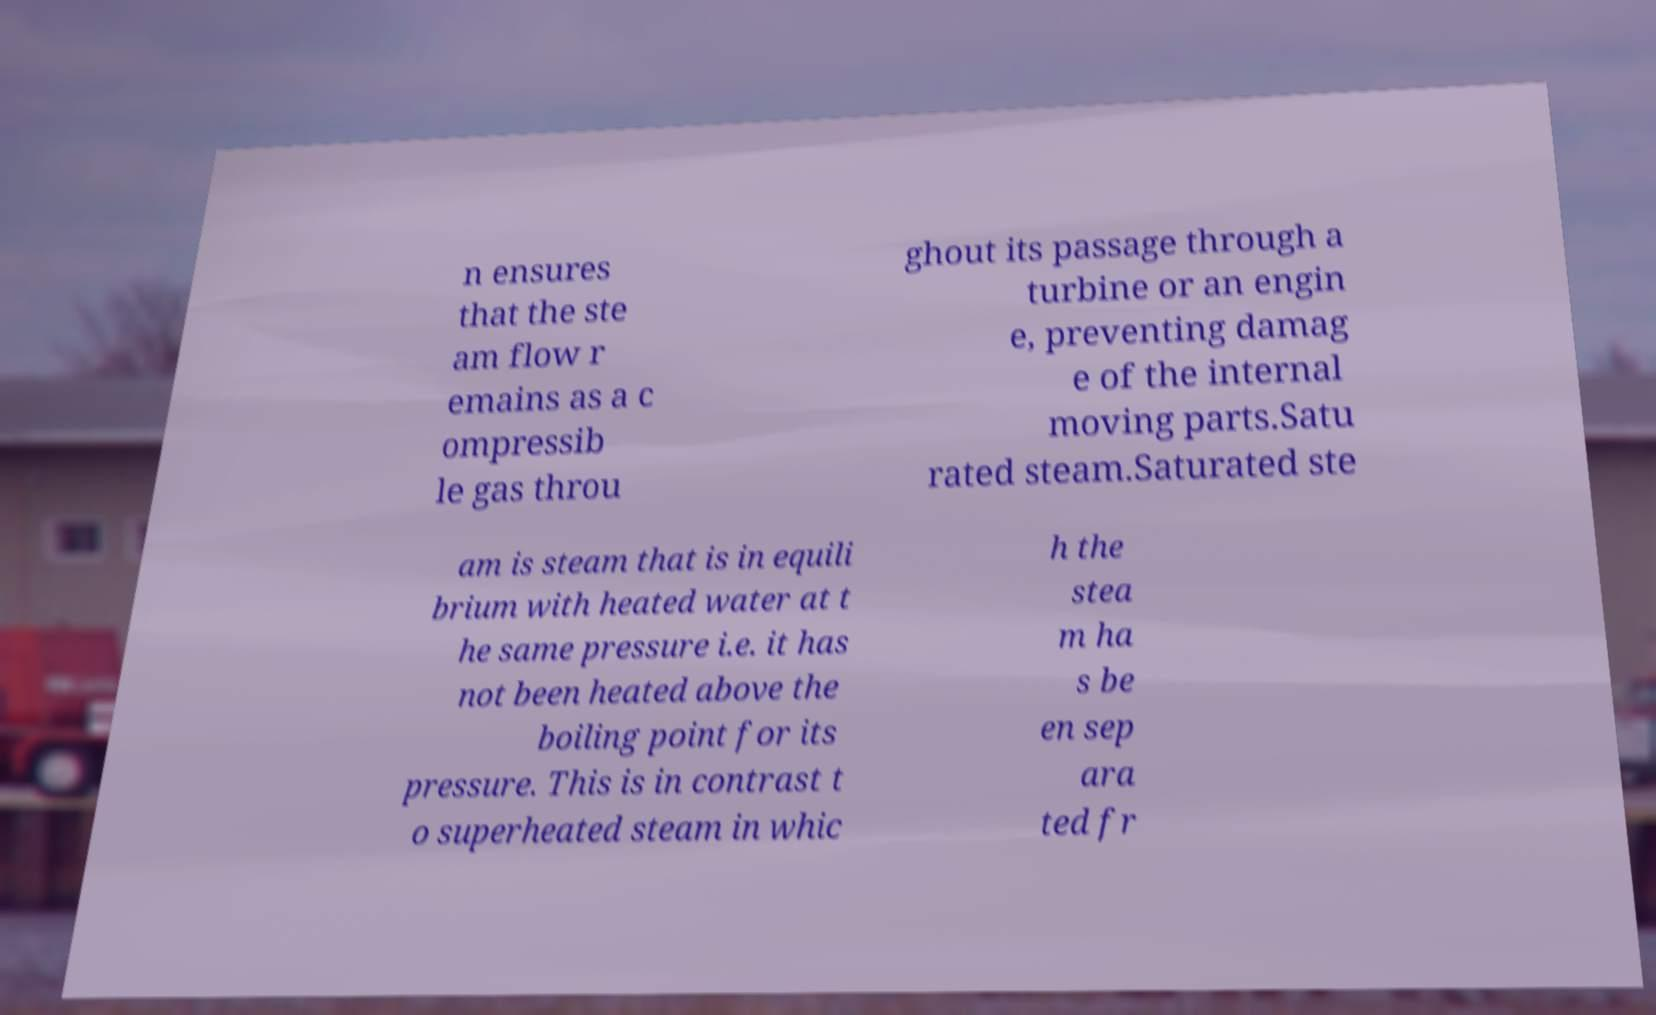For documentation purposes, I need the text within this image transcribed. Could you provide that? n ensures that the ste am flow r emains as a c ompressib le gas throu ghout its passage through a turbine or an engin e, preventing damag e of the internal moving parts.Satu rated steam.Saturated ste am is steam that is in equili brium with heated water at t he same pressure i.e. it has not been heated above the boiling point for its pressure. This is in contrast t o superheated steam in whic h the stea m ha s be en sep ara ted fr 